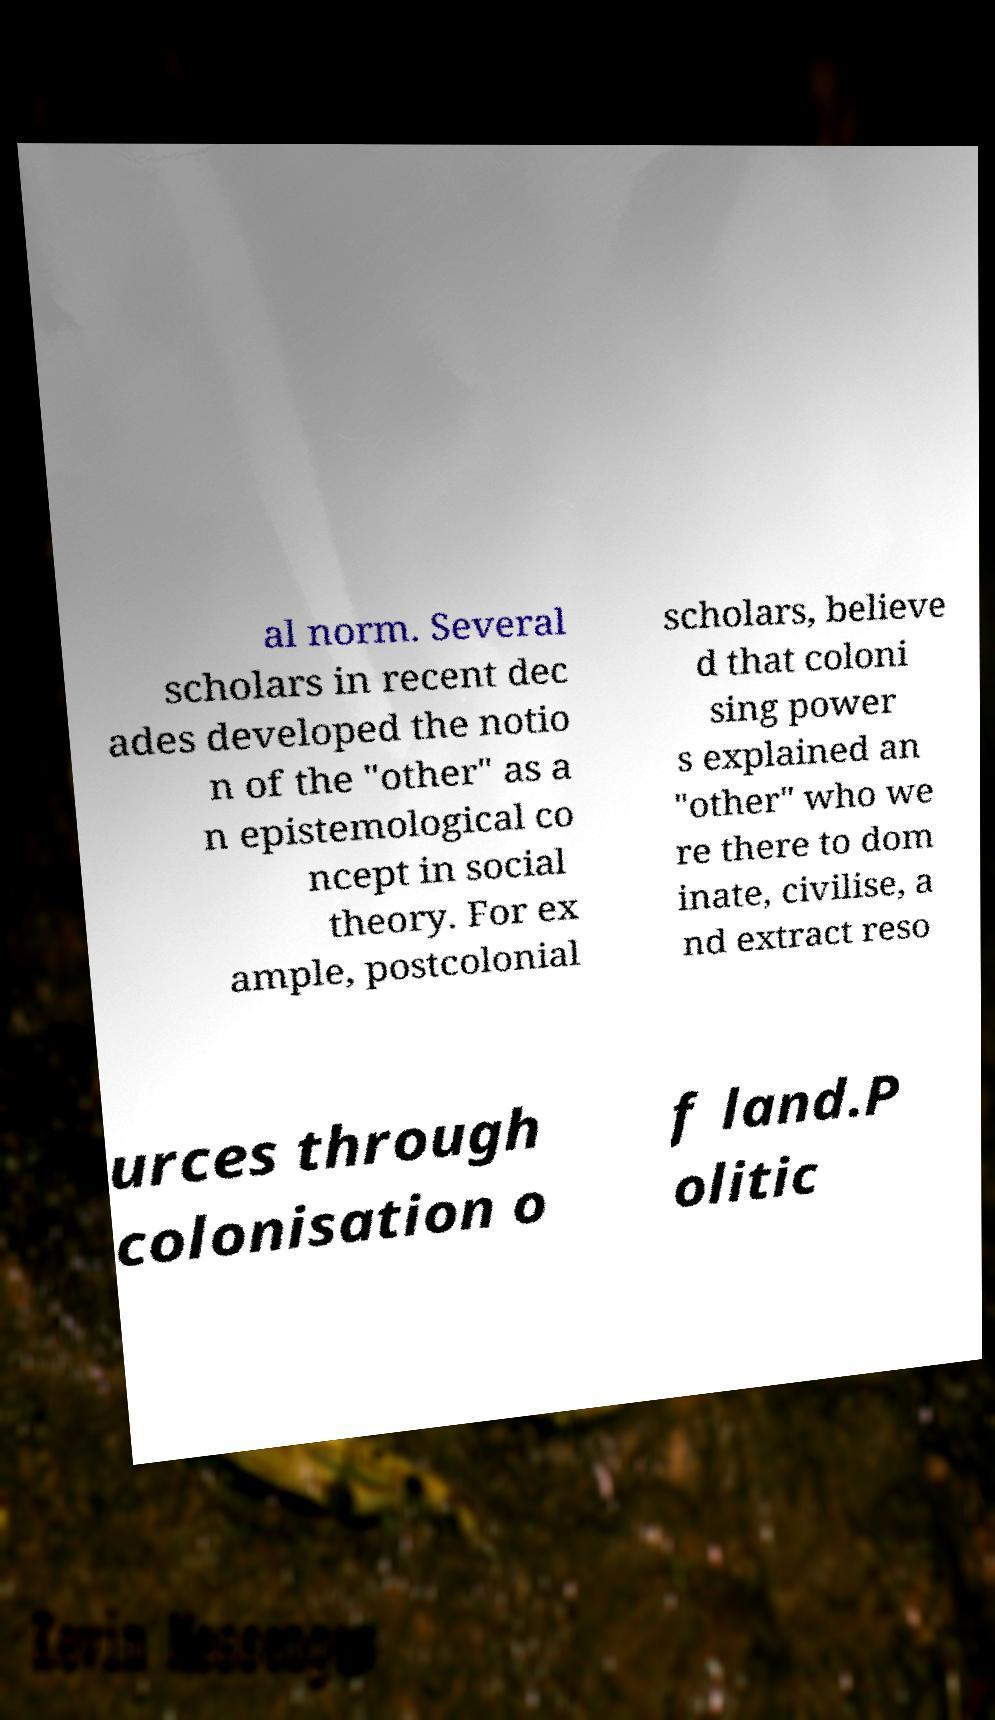Could you extract and type out the text from this image? al norm. Several scholars in recent dec ades developed the notio n of the "other" as a n epistemological co ncept in social theory. For ex ample, postcolonial scholars, believe d that coloni sing power s explained an "other" who we re there to dom inate, civilise, a nd extract reso urces through colonisation o f land.P olitic 